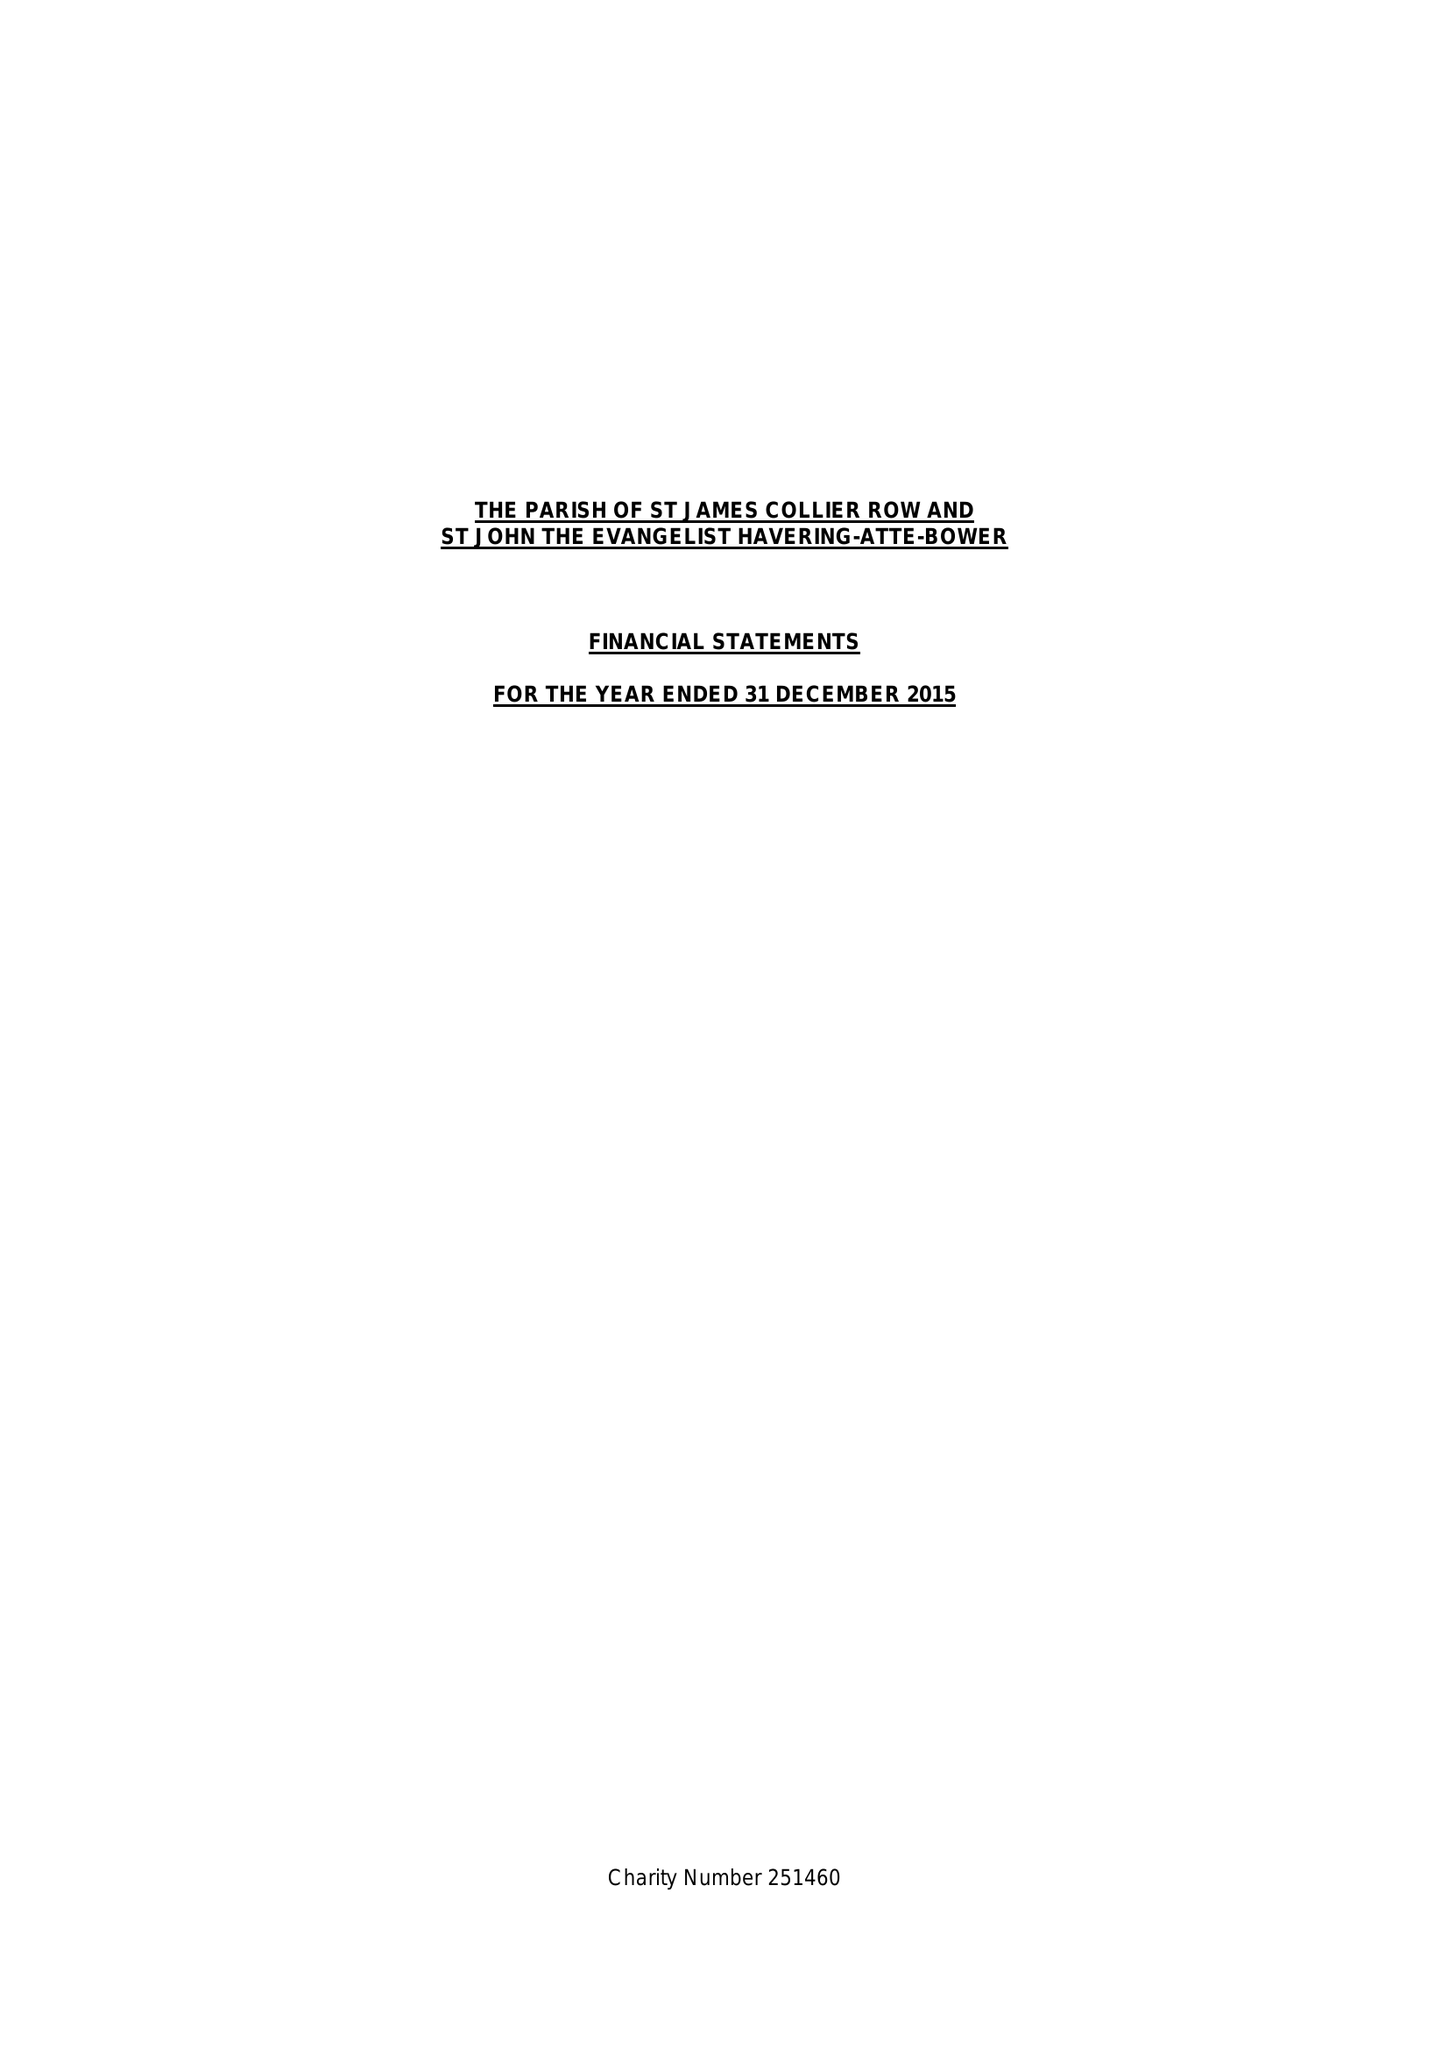What is the value for the report_date?
Answer the question using a single word or phrase. 2015-12-31 